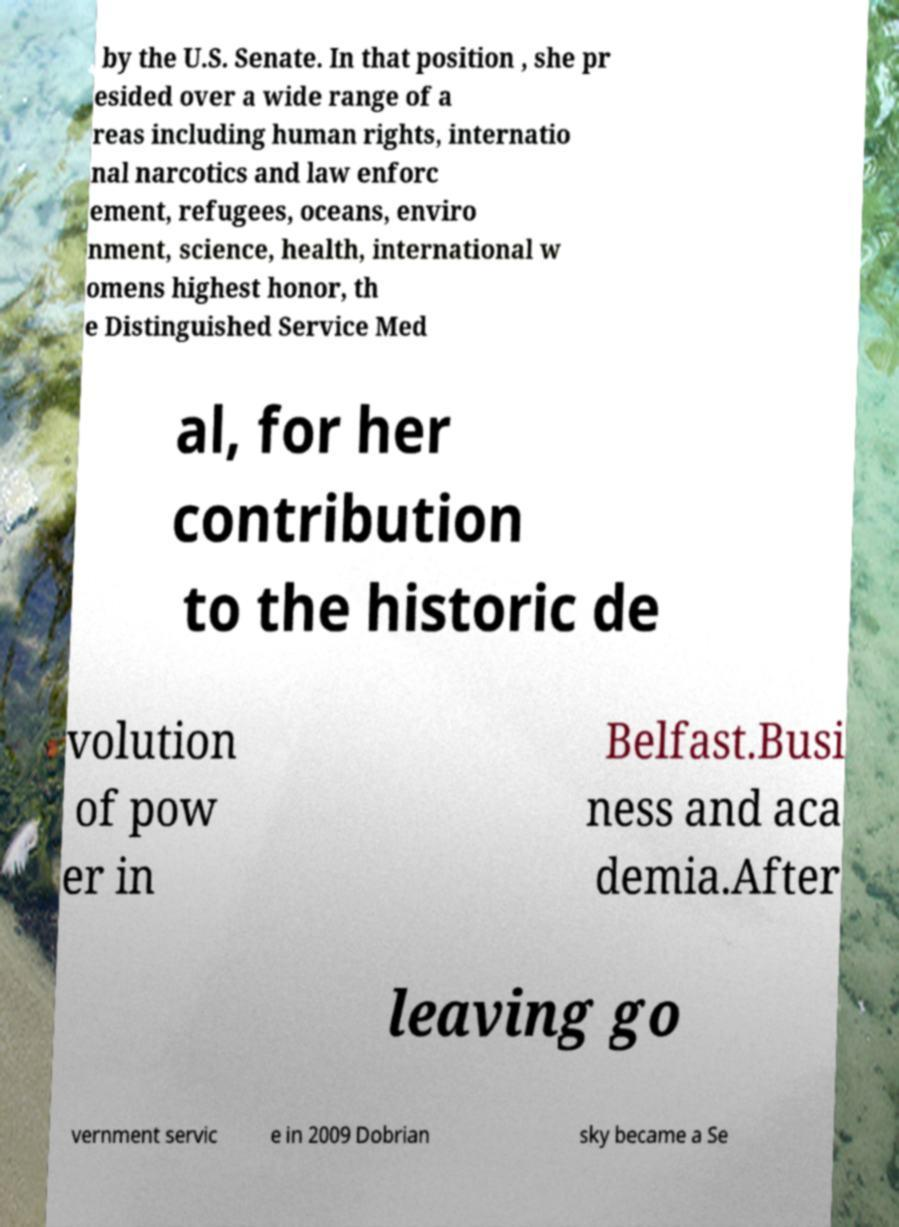Could you assist in decoding the text presented in this image and type it out clearly? by the U.S. Senate. In that position , she pr esided over a wide range of a reas including human rights, internatio nal narcotics and law enforc ement, refugees, oceans, enviro nment, science, health, international w omens highest honor, th e Distinguished Service Med al, for her contribution to the historic de volution of pow er in Belfast.Busi ness and aca demia.After leaving go vernment servic e in 2009 Dobrian sky became a Se 